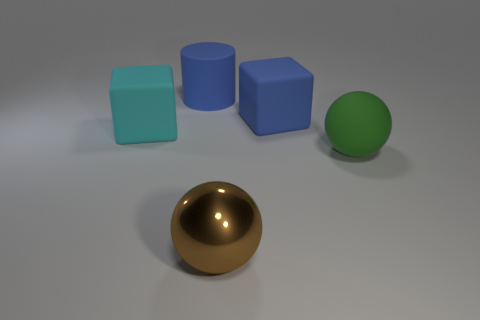Add 4 tiny red metal blocks. How many objects exist? 9 Subtract all spheres. How many objects are left? 3 Subtract all blue rubber things. Subtract all metal things. How many objects are left? 2 Add 1 balls. How many balls are left? 3 Add 4 large metal balls. How many large metal balls exist? 5 Subtract 0 yellow balls. How many objects are left? 5 